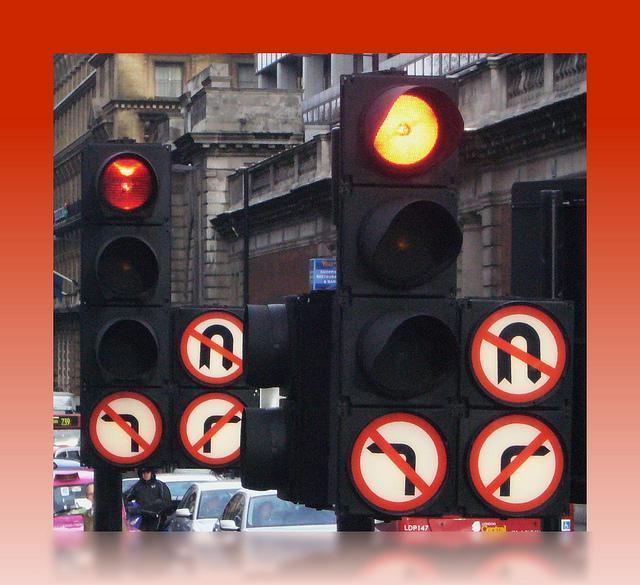How many traffic lights are there?
Give a very brief answer. 2. How many cars are there?
Give a very brief answer. 3. 